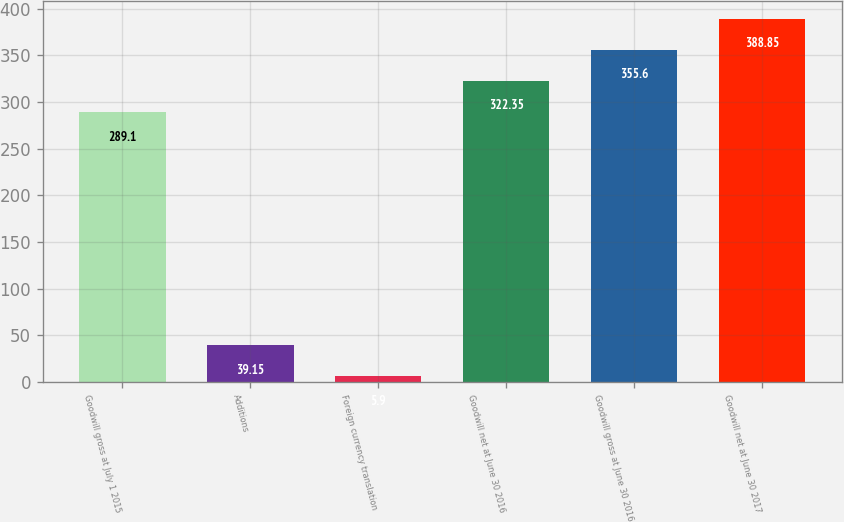<chart> <loc_0><loc_0><loc_500><loc_500><bar_chart><fcel>Goodwill gross at July 1 2015<fcel>Additions<fcel>Foreign currency translation<fcel>Goodwill net at June 30 2016<fcel>Goodwill gross at June 30 2016<fcel>Goodwill net at June 30 2017<nl><fcel>289.1<fcel>39.15<fcel>5.9<fcel>322.35<fcel>355.6<fcel>388.85<nl></chart> 